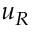Convert formula to latex. <formula><loc_0><loc_0><loc_500><loc_500>u _ { R }</formula> 